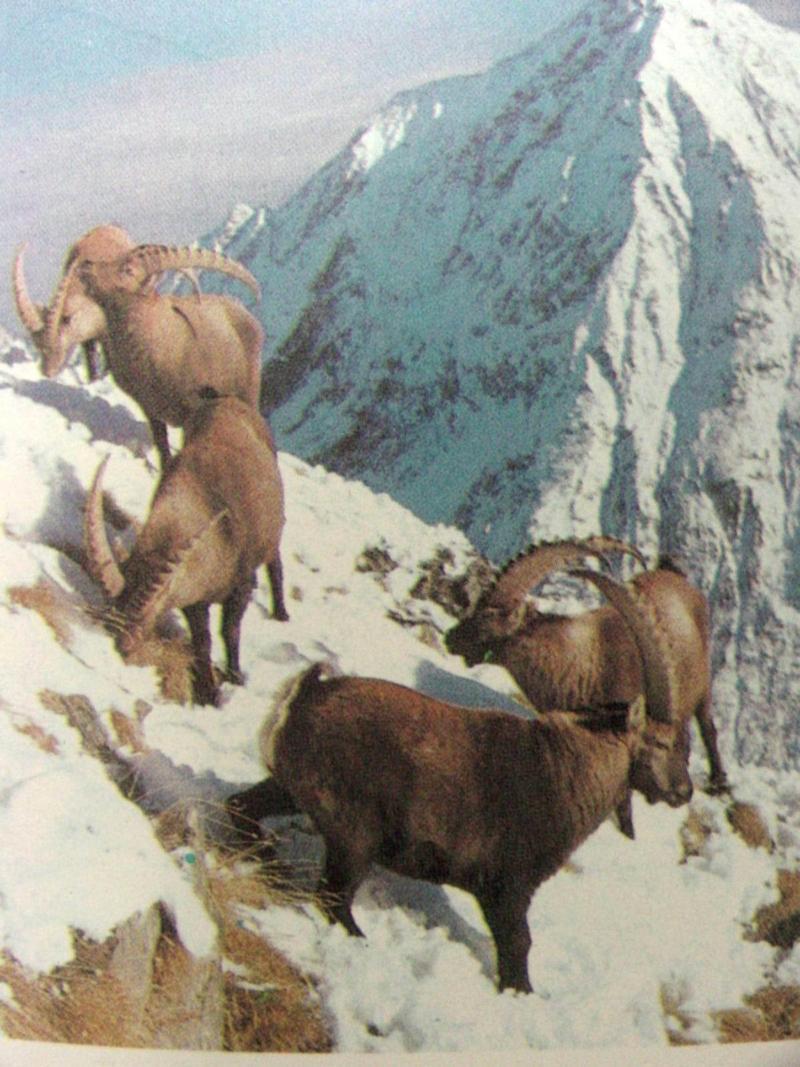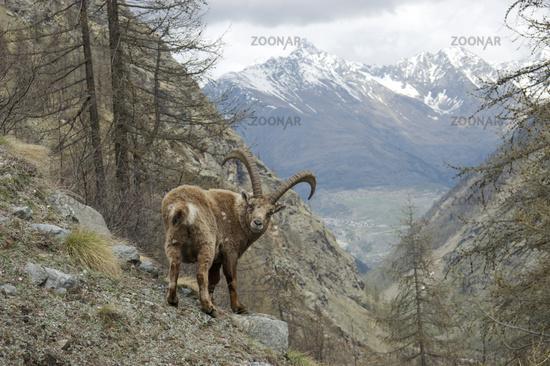The first image is the image on the left, the second image is the image on the right. Examine the images to the left and right. Is the description "A mountain goat stands on its hinds legs in front of a similarly colored horned animal." accurate? Answer yes or no. No. The first image is the image on the left, the second image is the image on the right. Examine the images to the left and right. Is the description "The left image contains exactly two mountain goats." accurate? Answer yes or no. No. 